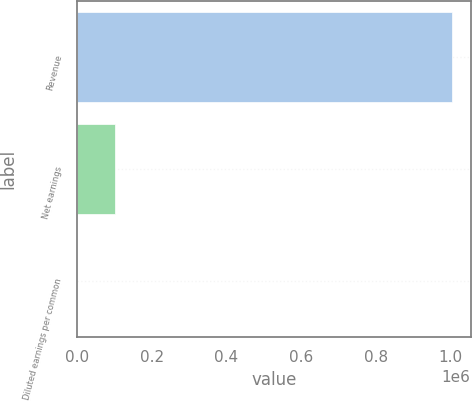Convert chart. <chart><loc_0><loc_0><loc_500><loc_500><bar_chart><fcel>Revenue<fcel>Net earnings<fcel>Diluted earnings per common<nl><fcel>1.00311e+06<fcel>100312<fcel>1.21<nl></chart> 